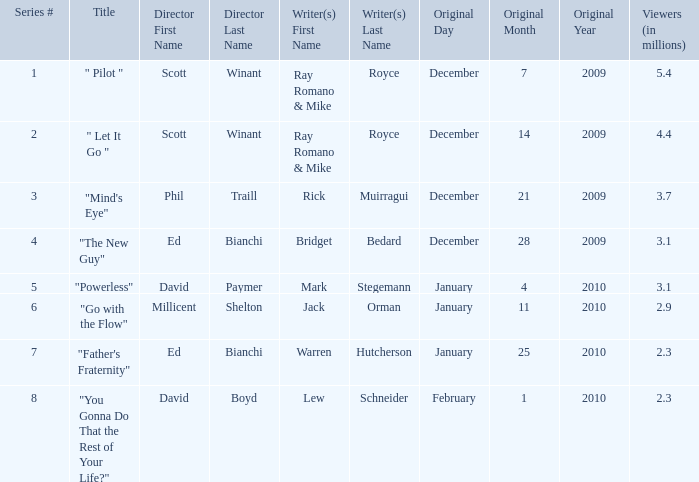How many episodes has lew schneider written? 1.0. 